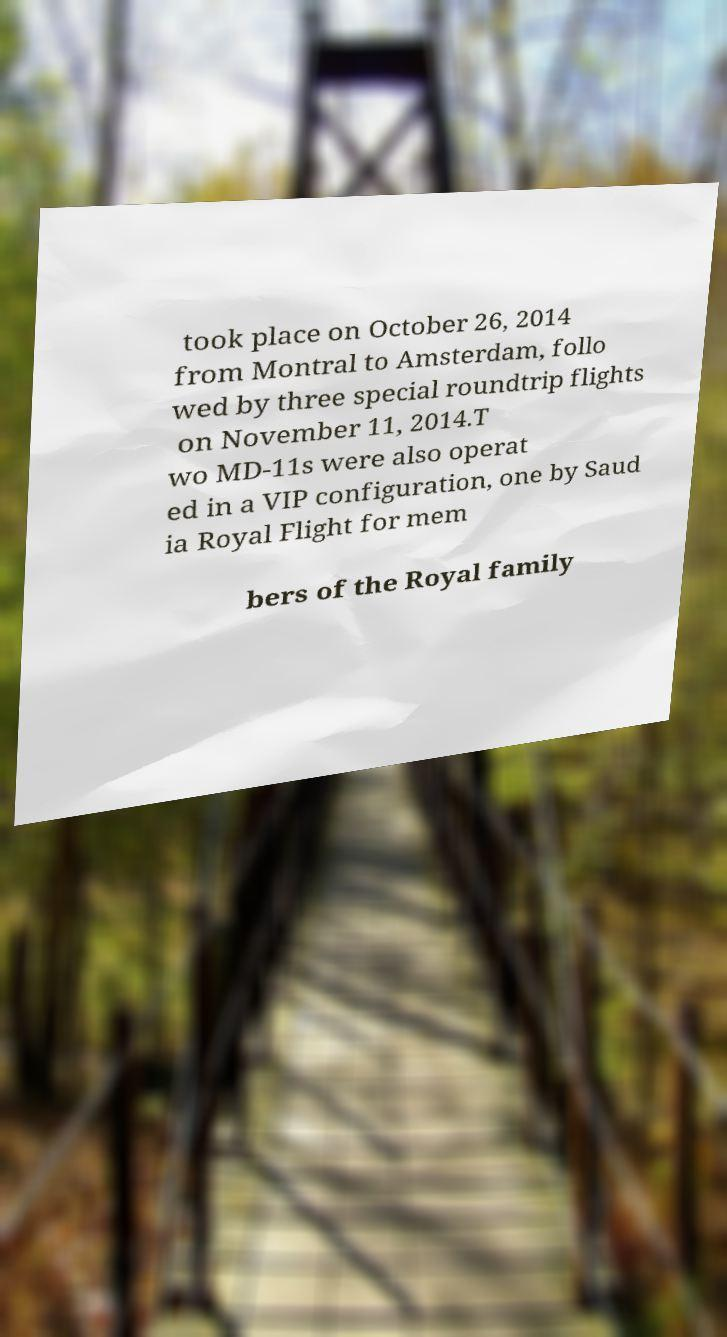Could you extract and type out the text from this image? took place on October 26, 2014 from Montral to Amsterdam, follo wed by three special roundtrip flights on November 11, 2014.T wo MD-11s were also operat ed in a VIP configuration, one by Saud ia Royal Flight for mem bers of the Royal family 